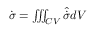<formula> <loc_0><loc_0><loc_500><loc_500>\begin{array} { r } { { \dot { \sigma } } = \iiint _ { C V } { \hat { \dot { \sigma } } } d V } \end{array}</formula> 